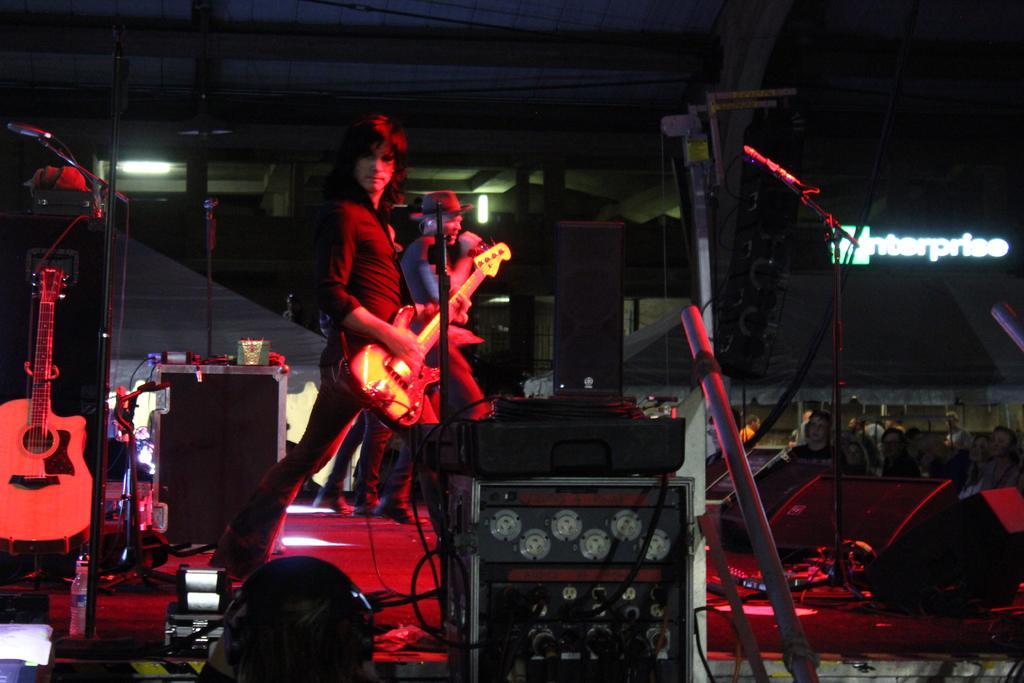Can you describe this image briefly? In this picture there are some people standing on the stage. Woman is playing a guitar. Behind her there is another guy wearing a hat and singing in front of a microphone. There are some speakers and equipment in front of a woman. In the background there is a wall. 